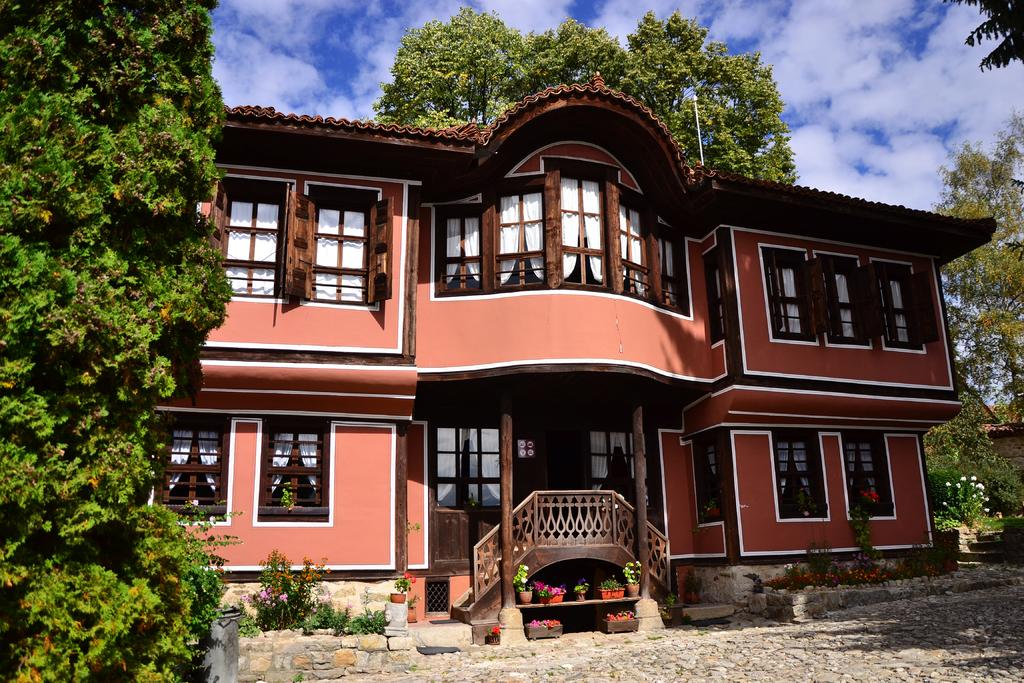What type of structure is visible in the image? There is a building in the image. What features can be seen on the building? The building has windows. What type of window treatment is present in the image? There are curtains in the image. What type of vegetation is present in the image? There are plants, flowers, and trees in the image. What part of the natural environment is visible in the image? The sky is visible in the image, and clouds are present in the sky. What type of net is being used to catch the birds in the image? There is no net present in the image, nor are there any birds. 